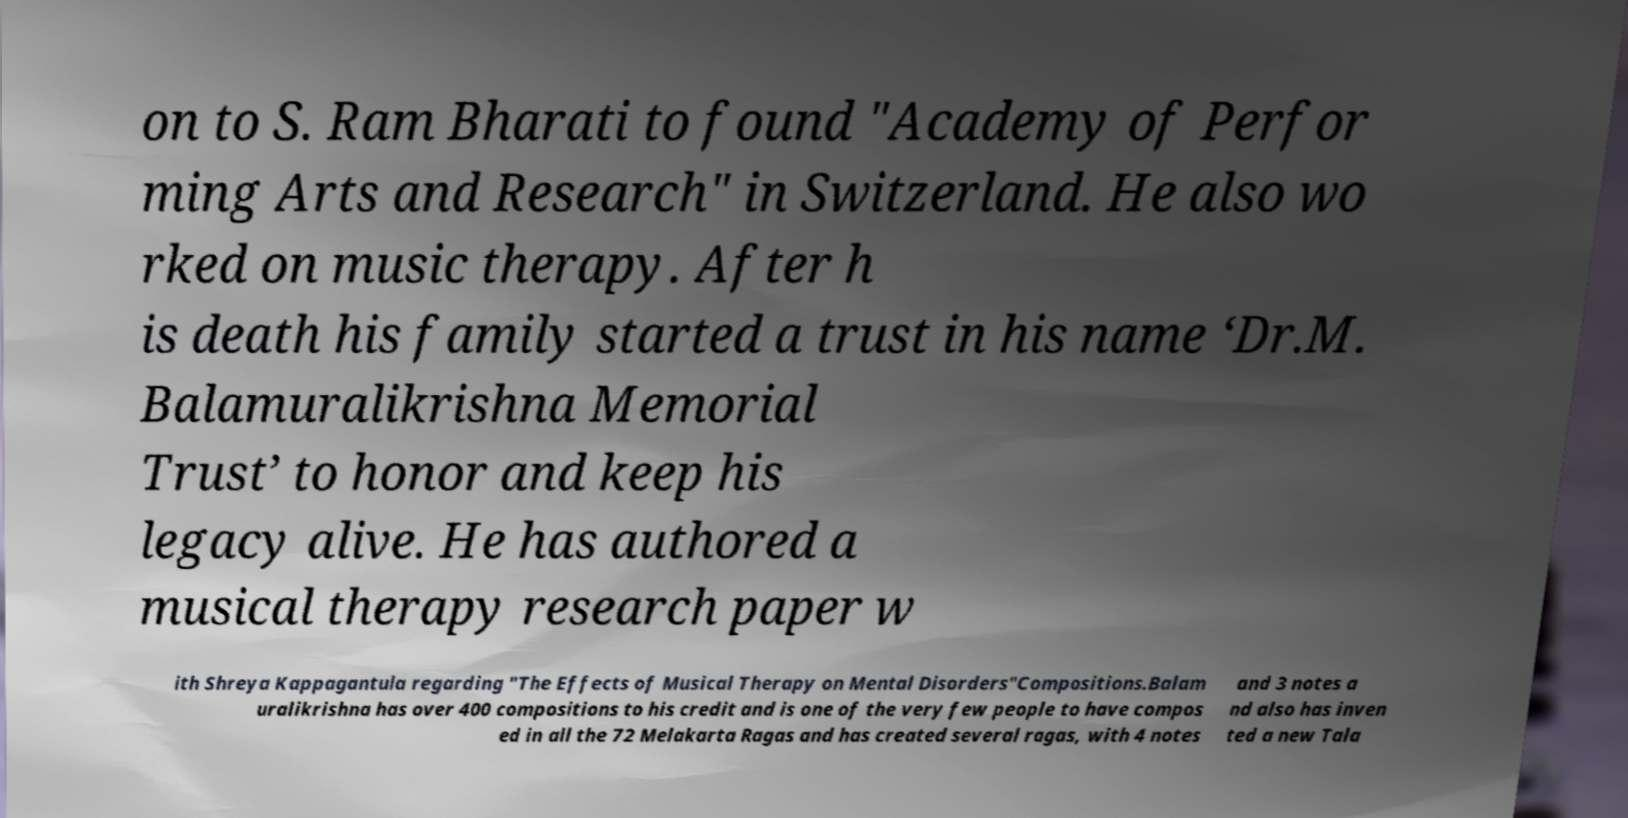Can you accurately transcribe the text from the provided image for me? on to S. Ram Bharati to found "Academy of Perfor ming Arts and Research" in Switzerland. He also wo rked on music therapy. After h is death his family started a trust in his name ‘Dr.M. Balamuralikrishna Memorial Trust’ to honor and keep his legacy alive. He has authored a musical therapy research paper w ith Shreya Kappagantula regarding "The Effects of Musical Therapy on Mental Disorders"Compositions.Balam uralikrishna has over 400 compositions to his credit and is one of the very few people to have compos ed in all the 72 Melakarta Ragas and has created several ragas, with 4 notes and 3 notes a nd also has inven ted a new Tala 